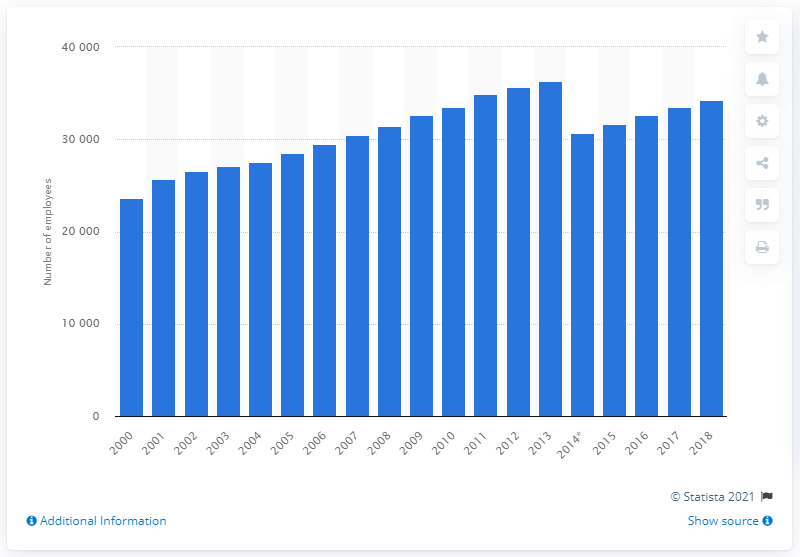List a handful of essential elements in this visual. In 2018, there were approximately 34,280 physiotherapists employed in the healthcare sector in the Netherlands. 